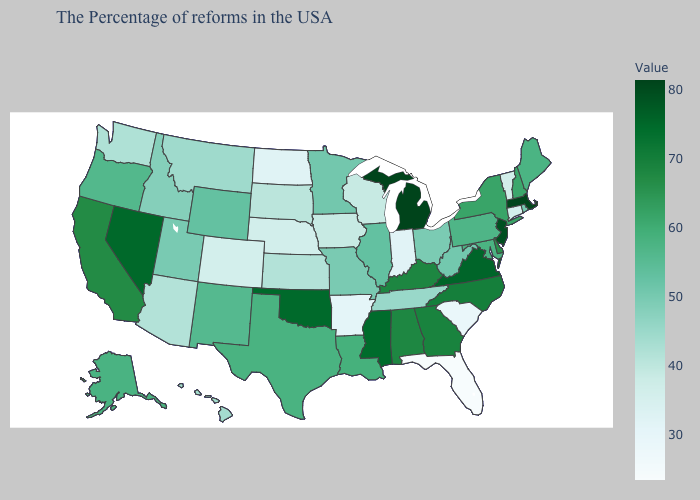Which states have the lowest value in the USA?
Be succinct. Florida. Does New Hampshire have the lowest value in the Northeast?
Short answer required. No. Among the states that border Nebraska , which have the highest value?
Short answer required. Wyoming. Does South Dakota have a higher value than Indiana?
Short answer required. Yes. Does the map have missing data?
Write a very short answer. No. Is the legend a continuous bar?
Answer briefly. Yes. Does the map have missing data?
Write a very short answer. No. Is the legend a continuous bar?
Give a very brief answer. Yes. 